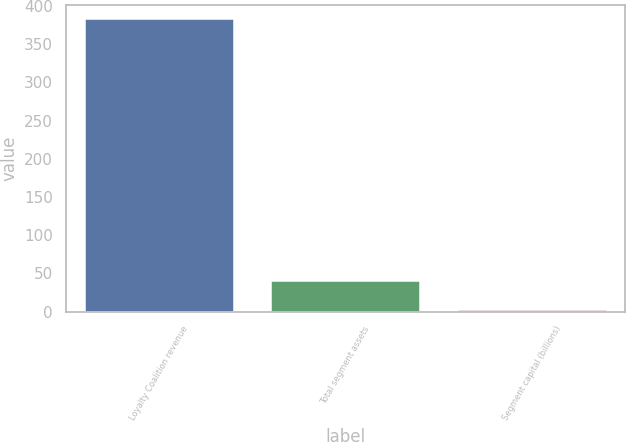Convert chart. <chart><loc_0><loc_0><loc_500><loc_500><bar_chart><fcel>Loyalty Coalition revenue<fcel>Total segment assets<fcel>Segment capital (billions)<nl><fcel>383<fcel>40.19<fcel>2.1<nl></chart> 